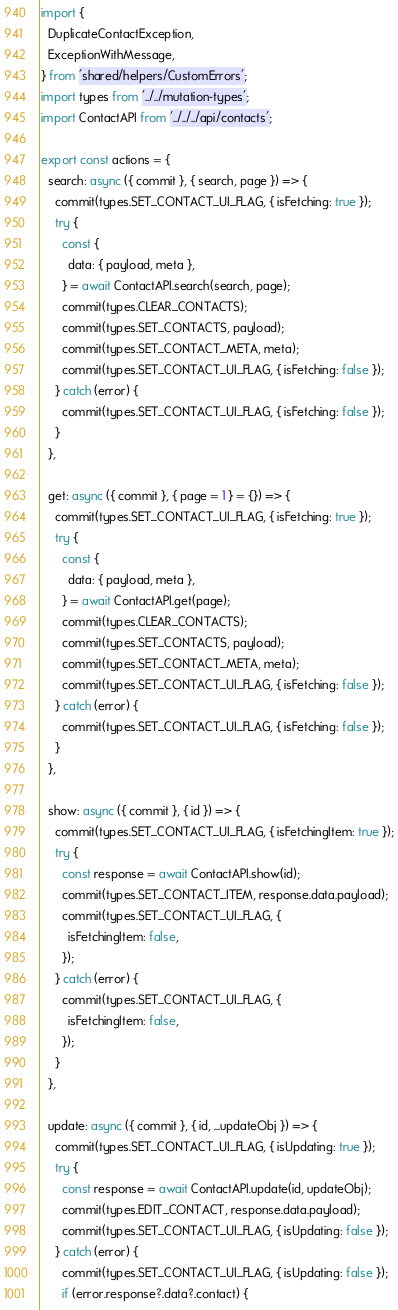Convert code to text. <code><loc_0><loc_0><loc_500><loc_500><_JavaScript_>import {
  DuplicateContactException,
  ExceptionWithMessage,
} from 'shared/helpers/CustomErrors';
import types from '../../mutation-types';
import ContactAPI from '../../../api/contacts';

export const actions = {
  search: async ({ commit }, { search, page }) => {
    commit(types.SET_CONTACT_UI_FLAG, { isFetching: true });
    try {
      const {
        data: { payload, meta },
      } = await ContactAPI.search(search, page);
      commit(types.CLEAR_CONTACTS);
      commit(types.SET_CONTACTS, payload);
      commit(types.SET_CONTACT_META, meta);
      commit(types.SET_CONTACT_UI_FLAG, { isFetching: false });
    } catch (error) {
      commit(types.SET_CONTACT_UI_FLAG, { isFetching: false });
    }
  },

  get: async ({ commit }, { page = 1 } = {}) => {
    commit(types.SET_CONTACT_UI_FLAG, { isFetching: true });
    try {
      const {
        data: { payload, meta },
      } = await ContactAPI.get(page);
      commit(types.CLEAR_CONTACTS);
      commit(types.SET_CONTACTS, payload);
      commit(types.SET_CONTACT_META, meta);
      commit(types.SET_CONTACT_UI_FLAG, { isFetching: false });
    } catch (error) {
      commit(types.SET_CONTACT_UI_FLAG, { isFetching: false });
    }
  },

  show: async ({ commit }, { id }) => {
    commit(types.SET_CONTACT_UI_FLAG, { isFetchingItem: true });
    try {
      const response = await ContactAPI.show(id);
      commit(types.SET_CONTACT_ITEM, response.data.payload);
      commit(types.SET_CONTACT_UI_FLAG, {
        isFetchingItem: false,
      });
    } catch (error) {
      commit(types.SET_CONTACT_UI_FLAG, {
        isFetchingItem: false,
      });
    }
  },

  update: async ({ commit }, { id, ...updateObj }) => {
    commit(types.SET_CONTACT_UI_FLAG, { isUpdating: true });
    try {
      const response = await ContactAPI.update(id, updateObj);
      commit(types.EDIT_CONTACT, response.data.payload);
      commit(types.SET_CONTACT_UI_FLAG, { isUpdating: false });
    } catch (error) {
      commit(types.SET_CONTACT_UI_FLAG, { isUpdating: false });
      if (error.response?.data?.contact) {</code> 